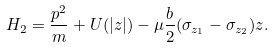Convert formula to latex. <formula><loc_0><loc_0><loc_500><loc_500>H _ { 2 } = \frac { p ^ { 2 } } { m } + U ( | z | ) - \mu \frac { b } { 2 } ( \sigma _ { z _ { 1 } } - \sigma _ { z _ { 2 } } ) z .</formula> 